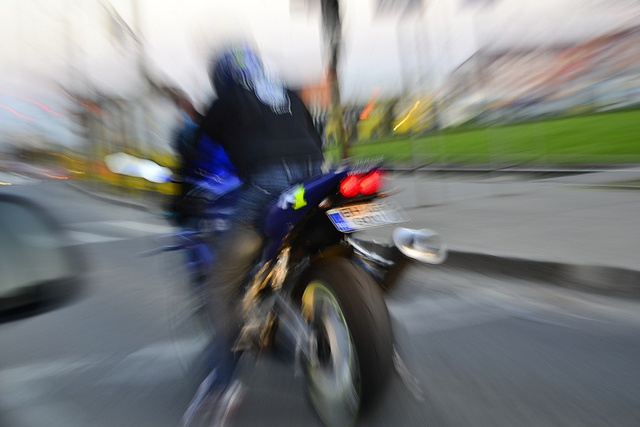Describe the objects in this image and their specific colors. I can see motorcycle in white, black, gray, darkgray, and navy tones and people in white, black, navy, gray, and darkgray tones in this image. 